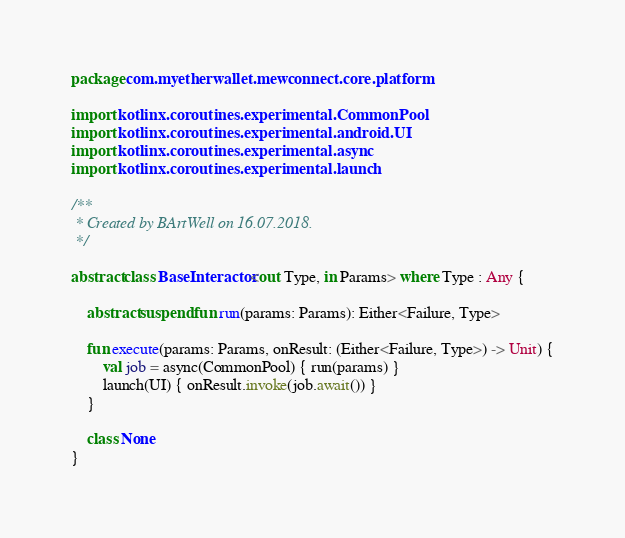Convert code to text. <code><loc_0><loc_0><loc_500><loc_500><_Kotlin_>package com.myetherwallet.mewconnect.core.platform

import kotlinx.coroutines.experimental.CommonPool
import kotlinx.coroutines.experimental.android.UI
import kotlinx.coroutines.experimental.async
import kotlinx.coroutines.experimental.launch

/**
 * Created by BArtWell on 16.07.2018.
 */

abstract class BaseInteractor<out Type, in Params> where Type : Any {

    abstract suspend fun run(params: Params): Either<Failure, Type>

    fun execute(params: Params, onResult: (Either<Failure, Type>) -> Unit) {
        val job = async(CommonPool) { run(params) }
        launch(UI) { onResult.invoke(job.await()) }
    }

    class None
}
</code> 